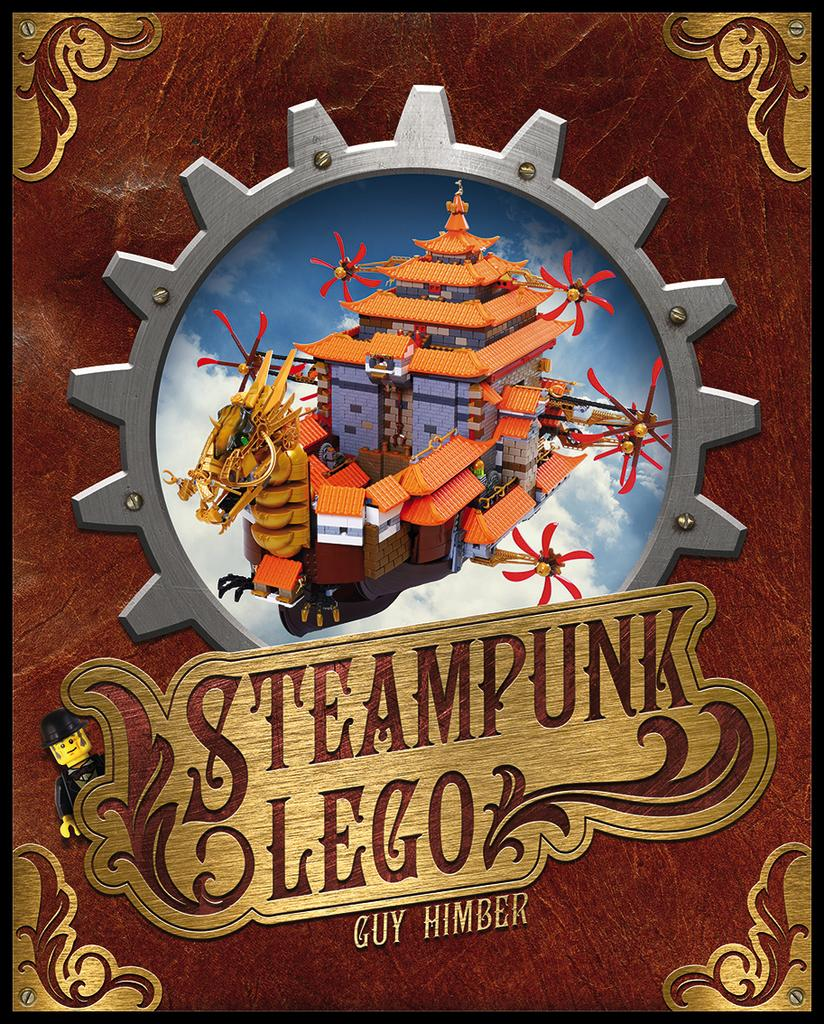Provide a one-sentence caption for the provided image. A poster of legos titled Steampunk Lego by Guy Himber. 